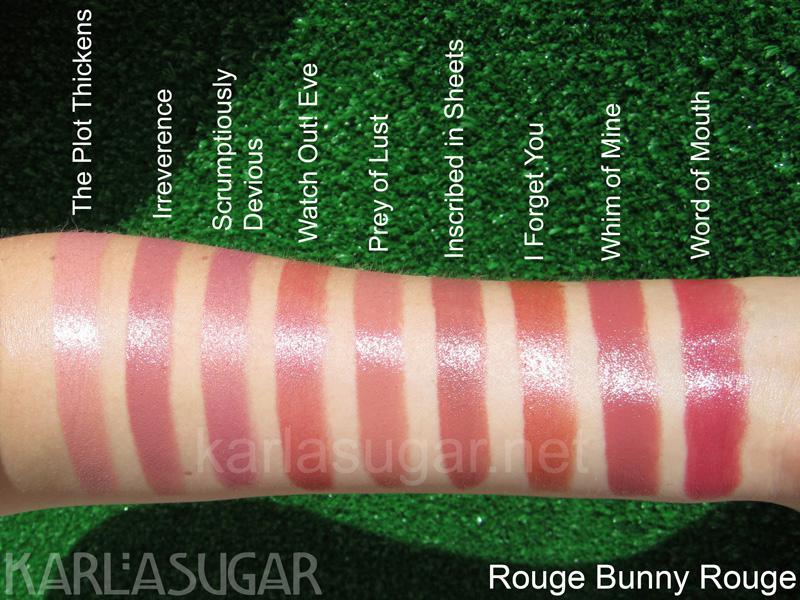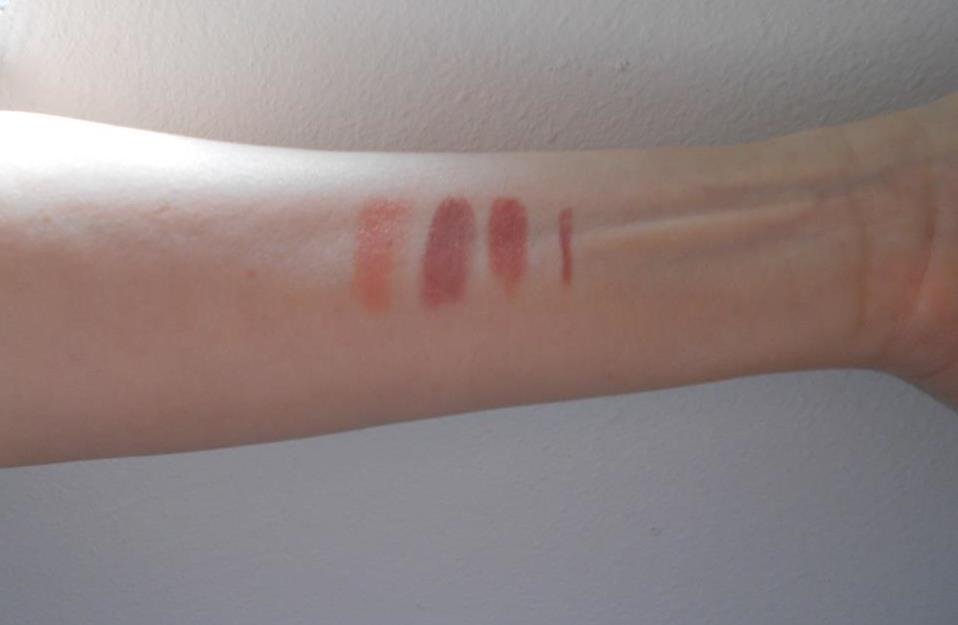The first image is the image on the left, the second image is the image on the right. Considering the images on both sides, is "One image features pink tinted lips with no teeth showing, and the other image shows multiple lipstick marks on skin." valid? Answer yes or no. No. The first image is the image on the left, the second image is the image on the right. For the images shown, is this caption "One image shows a lipstick shade displayed on lips and the other shows a variety of shades displayed on an arm." true? Answer yes or no. No. 